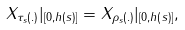<formula> <loc_0><loc_0><loc_500><loc_500>X _ { \tau _ { s } \left ( . \right ) } | _ { \left [ 0 , h \left ( s \right ) \right ] } = X _ { \rho _ { s } \left ( . \right ) } | _ { \left [ 0 , h \left ( s \right ) \right ] } ,</formula> 